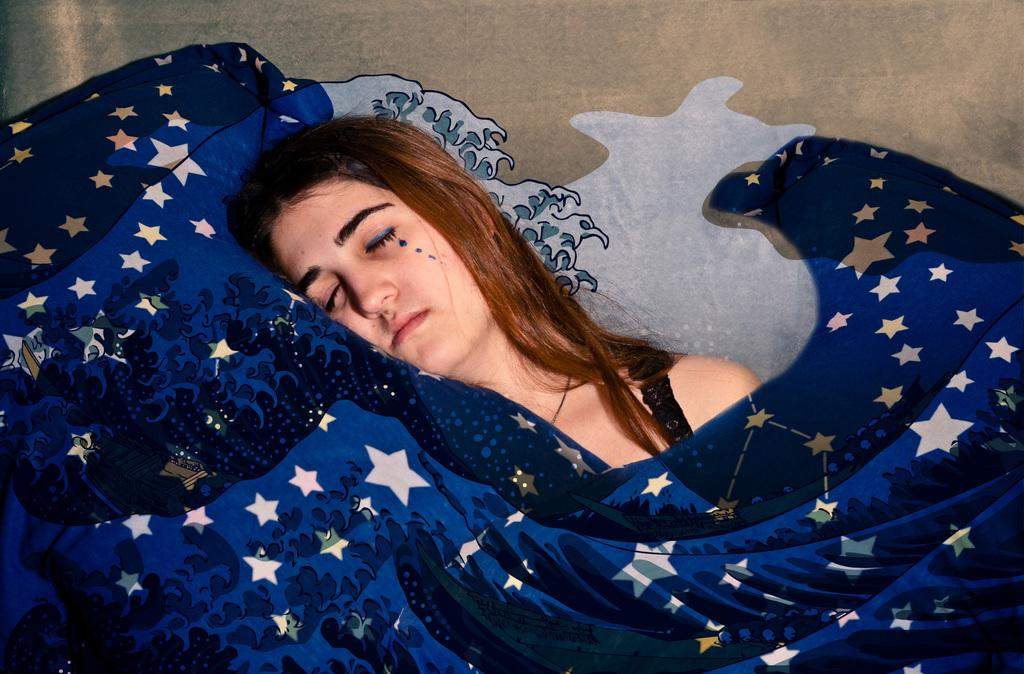Who is the main subject in the picture? There is a woman in the center of the picture. What can be seen in the foreground of the image? There is an object in the foreground. What is visible in the background of the image? There is a well in the background. What type of beast can be seen interacting with the corn in the image? There is no beast or corn present in the image. What is the occupation of the farmer in the image? There is no farmer present in the image. 